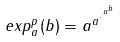Convert formula to latex. <formula><loc_0><loc_0><loc_500><loc_500>e x p _ { a } ^ { p } ( b ) = a ^ { a ^ { \cdot ^ { \cdot ^ { a ^ { b } } } } }</formula> 